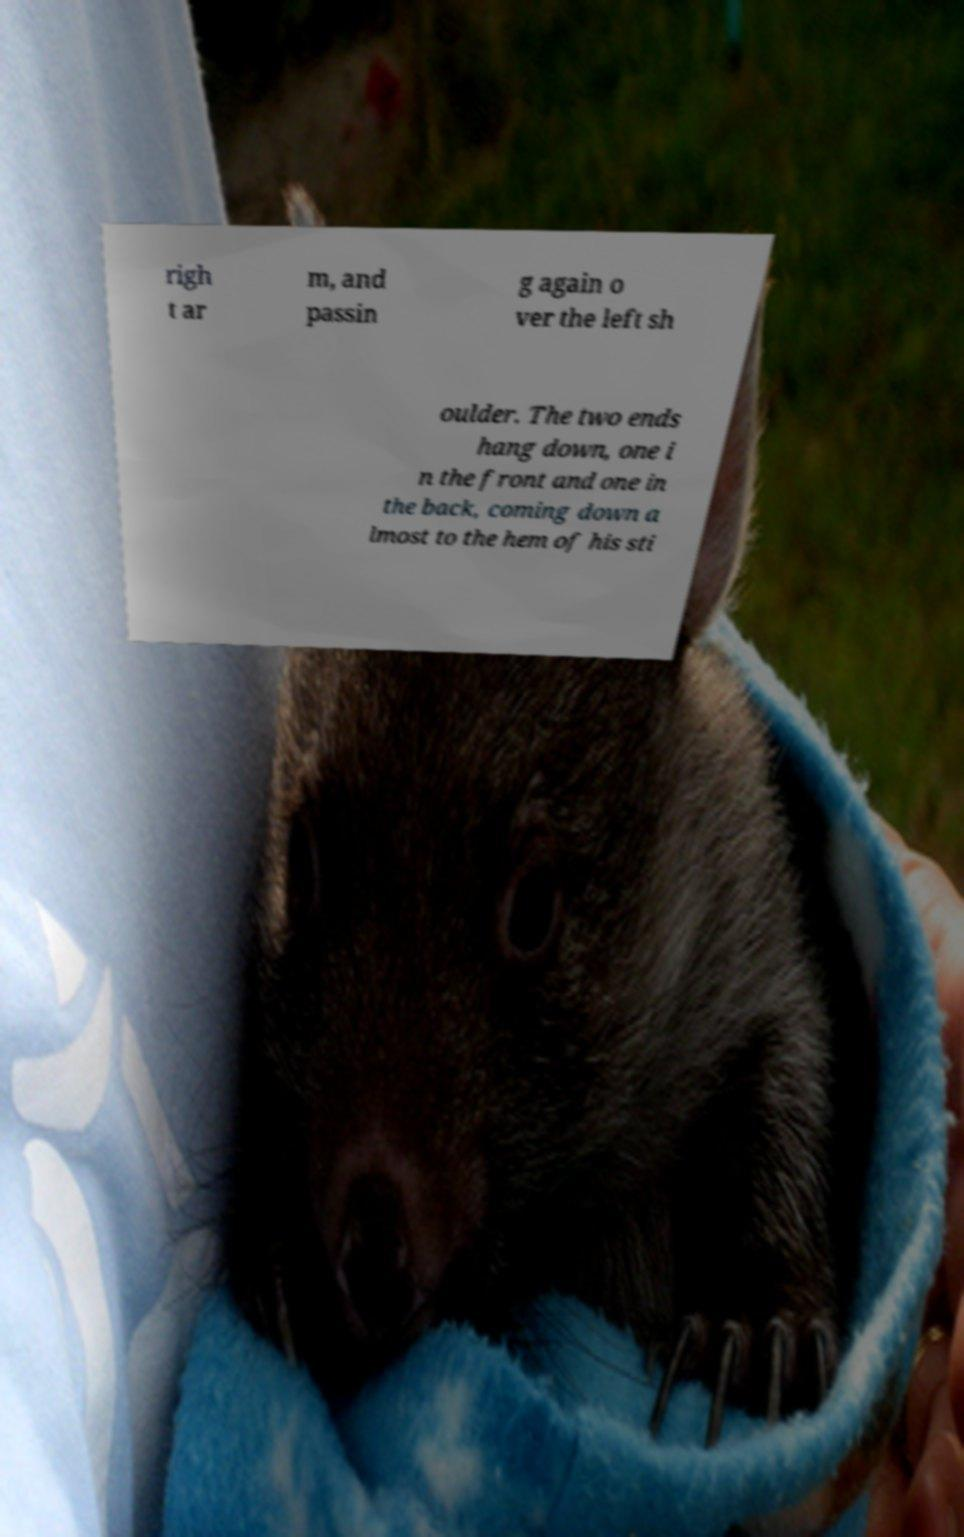Can you accurately transcribe the text from the provided image for me? righ t ar m, and passin g again o ver the left sh oulder. The two ends hang down, one i n the front and one in the back, coming down a lmost to the hem of his sti 